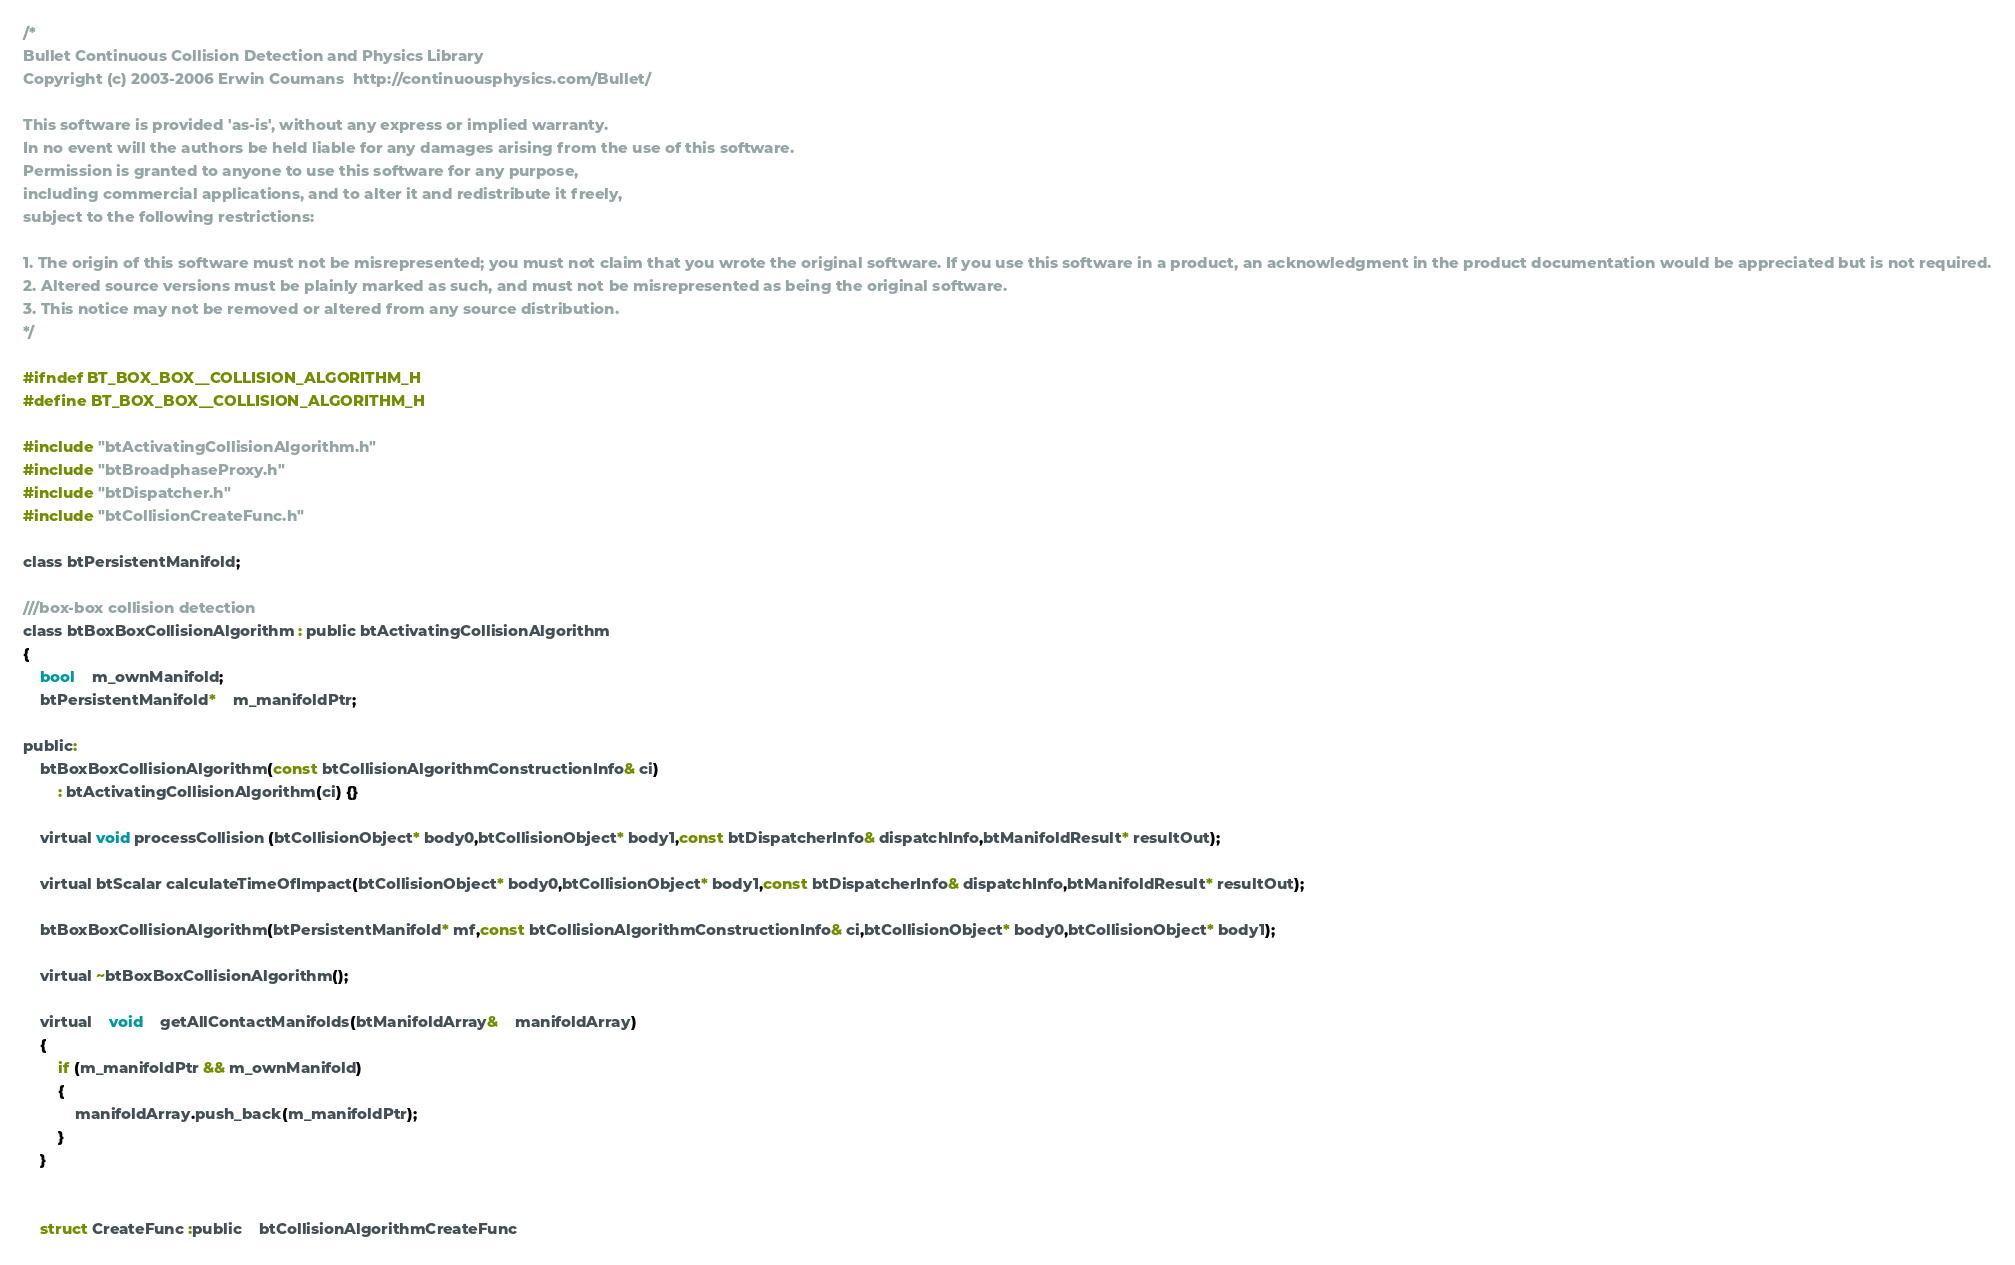<code> <loc_0><loc_0><loc_500><loc_500><_C_>/*
Bullet Continuous Collision Detection and Physics Library
Copyright (c) 2003-2006 Erwin Coumans  http://continuousphysics.com/Bullet/

This software is provided 'as-is', without any express or implied warranty.
In no event will the authors be held liable for any damages arising from the use of this software.
Permission is granted to anyone to use this software for any purpose, 
including commercial applications, and to alter it and redistribute it freely, 
subject to the following restrictions:

1. The origin of this software must not be misrepresented; you must not claim that you wrote the original software. If you use this software in a product, an acknowledgment in the product documentation would be appreciated but is not required.
2. Altered source versions must be plainly marked as such, and must not be misrepresented as being the original software.
3. This notice may not be removed or altered from any source distribution.
*/

#ifndef BT_BOX_BOX__COLLISION_ALGORITHM_H
#define BT_BOX_BOX__COLLISION_ALGORITHM_H

#include "btActivatingCollisionAlgorithm.h"
#include "btBroadphaseProxy.h"
#include "btDispatcher.h"
#include "btCollisionCreateFunc.h"

class btPersistentManifold;

///box-box collision detection
class btBoxBoxCollisionAlgorithm : public btActivatingCollisionAlgorithm
{
	bool	m_ownManifold;
	btPersistentManifold*	m_manifoldPtr;
	
public:
	btBoxBoxCollisionAlgorithm(const btCollisionAlgorithmConstructionInfo& ci)
		: btActivatingCollisionAlgorithm(ci) {}

	virtual void processCollision (btCollisionObject* body0,btCollisionObject* body1,const btDispatcherInfo& dispatchInfo,btManifoldResult* resultOut);

	virtual btScalar calculateTimeOfImpact(btCollisionObject* body0,btCollisionObject* body1,const btDispatcherInfo& dispatchInfo,btManifoldResult* resultOut);

	btBoxBoxCollisionAlgorithm(btPersistentManifold* mf,const btCollisionAlgorithmConstructionInfo& ci,btCollisionObject* body0,btCollisionObject* body1);

	virtual ~btBoxBoxCollisionAlgorithm();

	virtual	void	getAllContactManifolds(btManifoldArray&	manifoldArray)
	{
		if (m_manifoldPtr && m_ownManifold)
		{
			manifoldArray.push_back(m_manifoldPtr);
		}
	}


	struct CreateFunc :public 	btCollisionAlgorithmCreateFunc</code> 